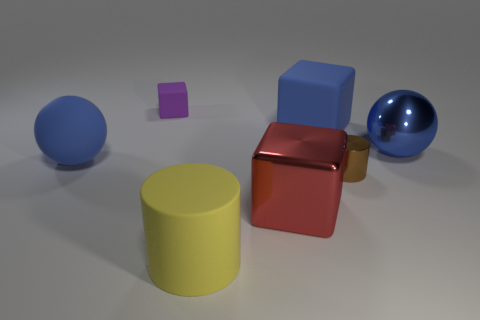What color is the matte cylinder that is the same size as the metal cube?
Provide a succinct answer. Yellow. How many other things are there of the same shape as the purple thing?
Offer a terse response. 2. Is the metallic cylinder the same size as the metal block?
Provide a succinct answer. No. Are there more tiny matte things to the left of the blue shiny sphere than purple rubber things to the left of the rubber sphere?
Keep it short and to the point. Yes. How many other objects are the same size as the purple block?
Give a very brief answer. 1. Do the large object that is on the left side of the big yellow thing and the small metallic thing have the same color?
Provide a short and direct response. No. Are there more blocks left of the big blue matte cube than tiny purple rubber things?
Offer a terse response. Yes. Is there anything else of the same color as the matte cylinder?
Keep it short and to the point. No. There is a big object that is on the right side of the blue rubber thing to the right of the red thing; what shape is it?
Offer a very short reply. Sphere. Are there more small brown things than rubber blocks?
Your answer should be compact. No. 